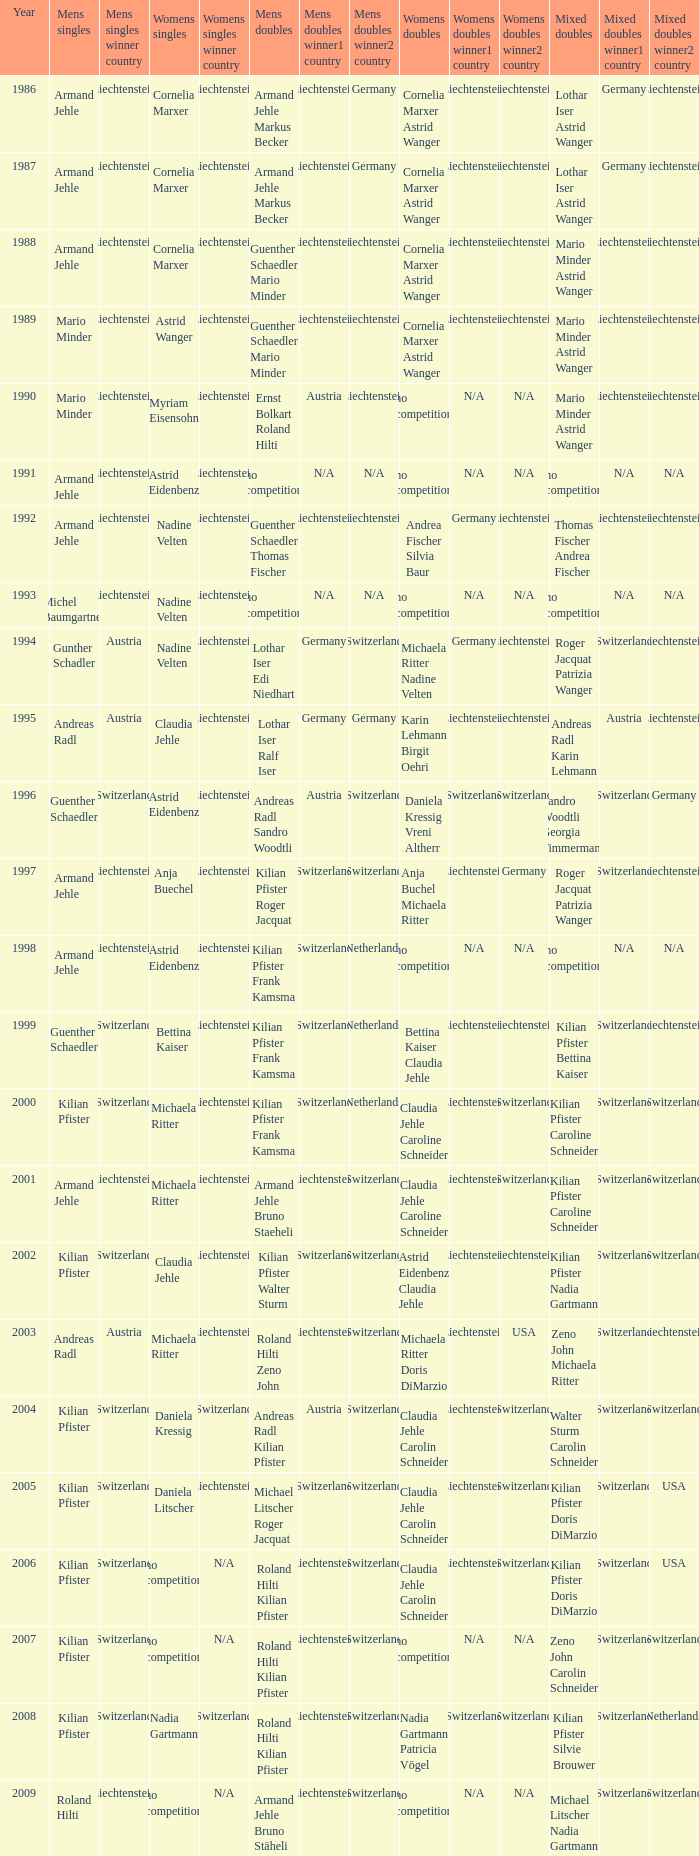In 2001, where the mens singles is armand jehle and the womens singles is michaela ritter, who are the mixed doubles Kilian Pfister Caroline Schneider. 